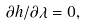<formula> <loc_0><loc_0><loc_500><loc_500>\partial h / \partial \lambda = 0 ,</formula> 